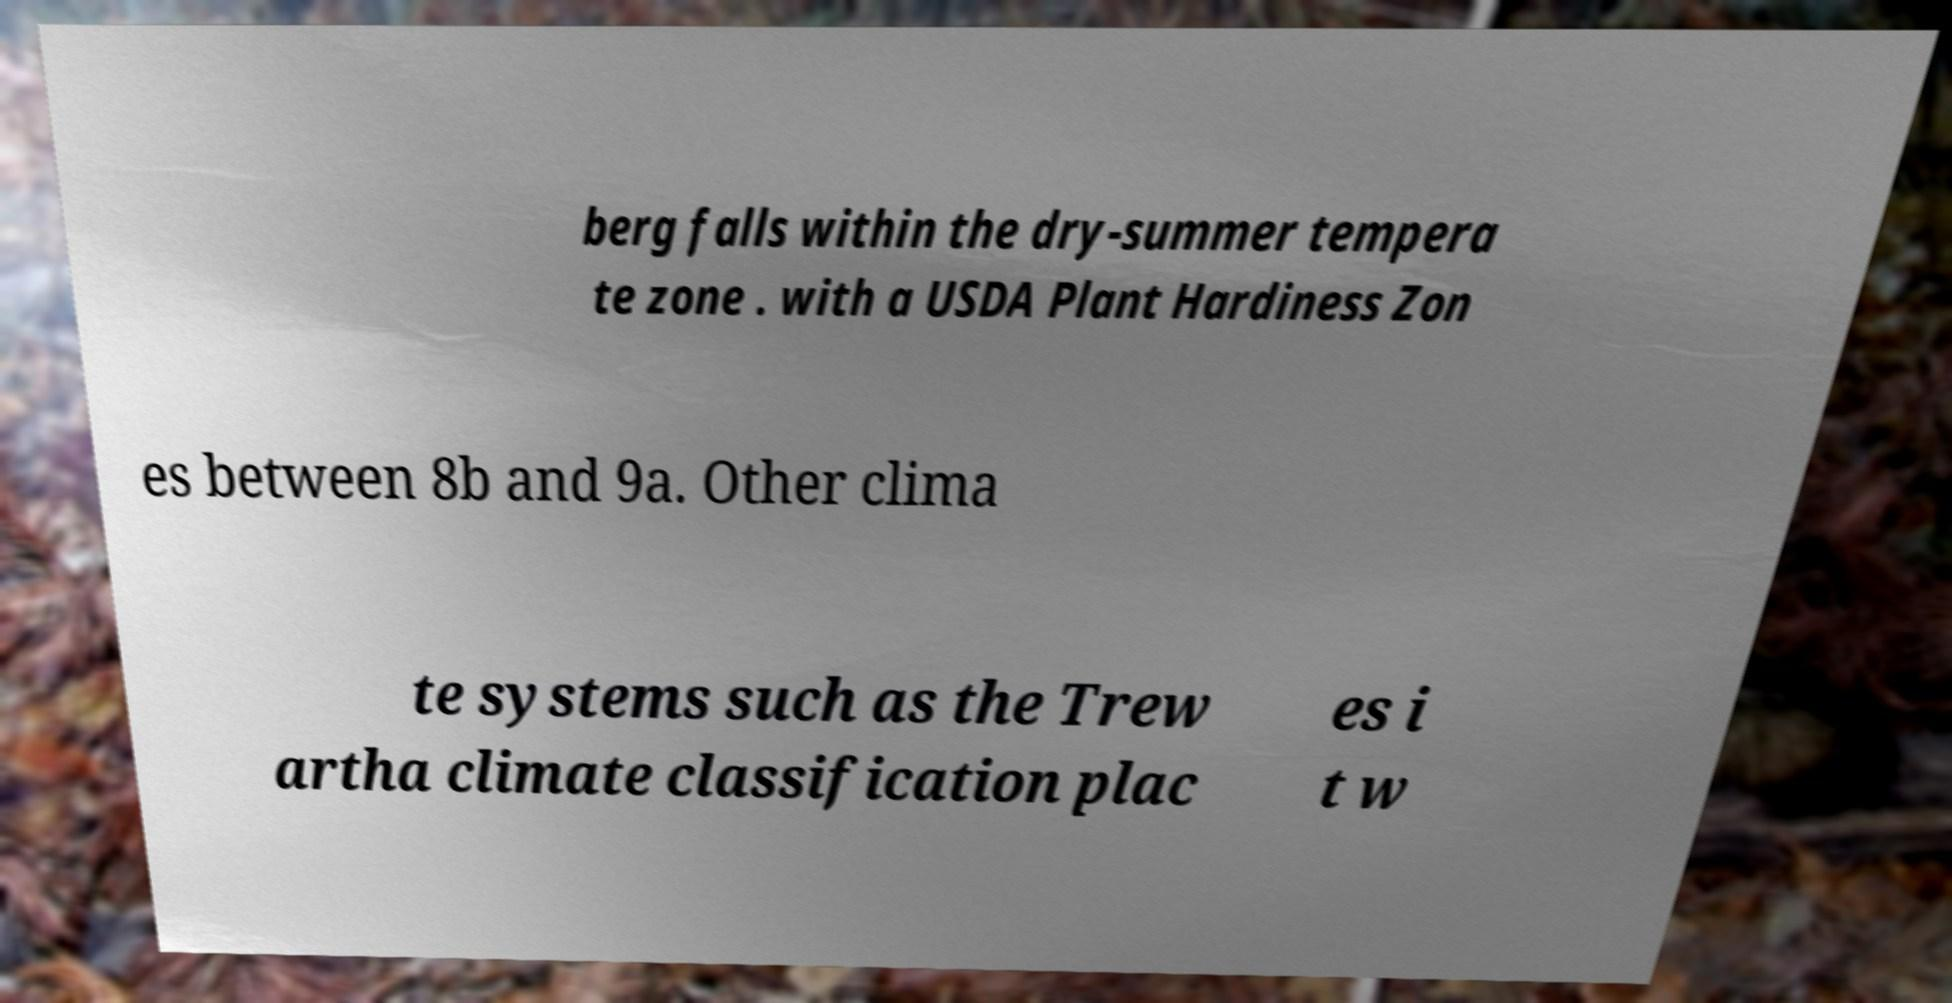I need the written content from this picture converted into text. Can you do that? berg falls within the dry-summer tempera te zone . with a USDA Plant Hardiness Zon es between 8b and 9a. Other clima te systems such as the Trew artha climate classification plac es i t w 